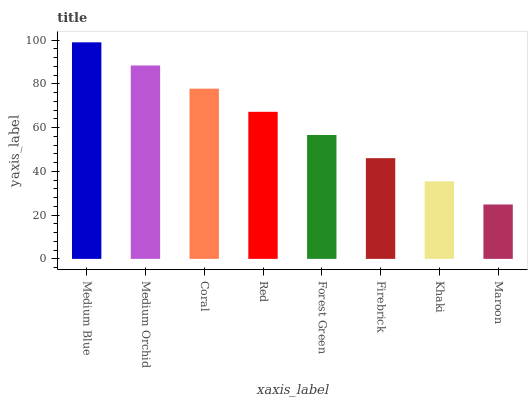Is Maroon the minimum?
Answer yes or no. Yes. Is Medium Blue the maximum?
Answer yes or no. Yes. Is Medium Orchid the minimum?
Answer yes or no. No. Is Medium Orchid the maximum?
Answer yes or no. No. Is Medium Blue greater than Medium Orchid?
Answer yes or no. Yes. Is Medium Orchid less than Medium Blue?
Answer yes or no. Yes. Is Medium Orchid greater than Medium Blue?
Answer yes or no. No. Is Medium Blue less than Medium Orchid?
Answer yes or no. No. Is Red the high median?
Answer yes or no. Yes. Is Forest Green the low median?
Answer yes or no. Yes. Is Medium Blue the high median?
Answer yes or no. No. Is Firebrick the low median?
Answer yes or no. No. 